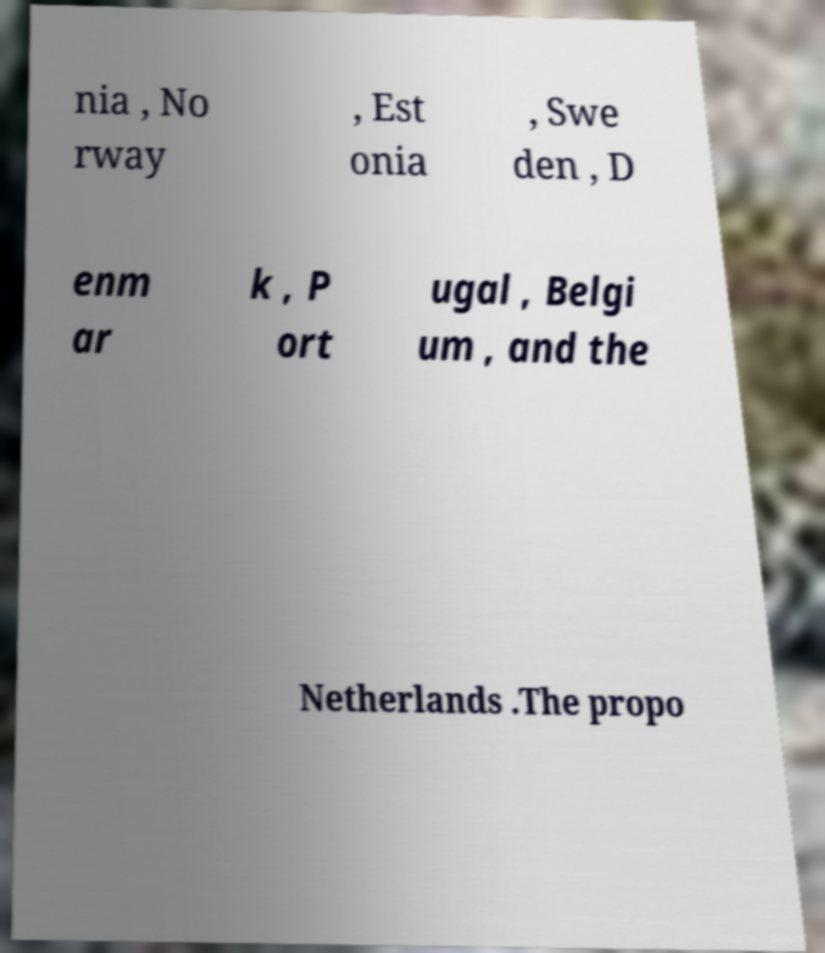Could you extract and type out the text from this image? nia , No rway , Est onia , Swe den , D enm ar k , P ort ugal , Belgi um , and the Netherlands .The propo 